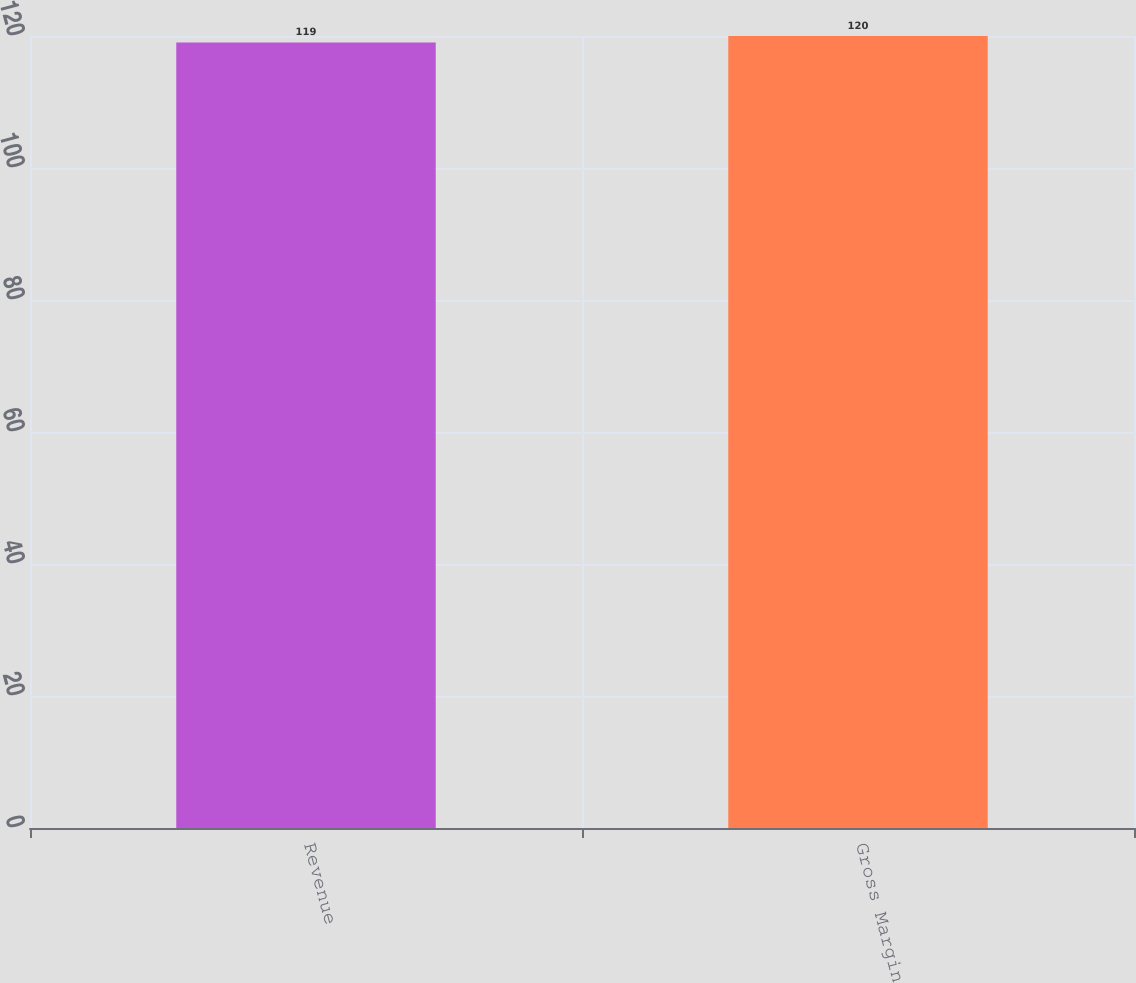<chart> <loc_0><loc_0><loc_500><loc_500><bar_chart><fcel>Revenue<fcel>Gross Margin<nl><fcel>119<fcel>120<nl></chart> 